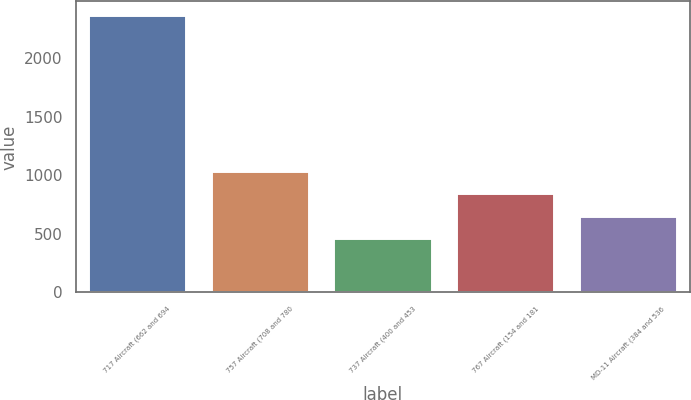<chart> <loc_0><loc_0><loc_500><loc_500><bar_chart><fcel>717 Aircraft (662 and 694<fcel>757 Aircraft (708 and 780<fcel>737 Aircraft (400 and 453<fcel>767 Aircraft (154 and 181<fcel>MD-11 Aircraft (384 and 536<nl><fcel>2365<fcel>1034.3<fcel>464<fcel>844.2<fcel>654.1<nl></chart> 